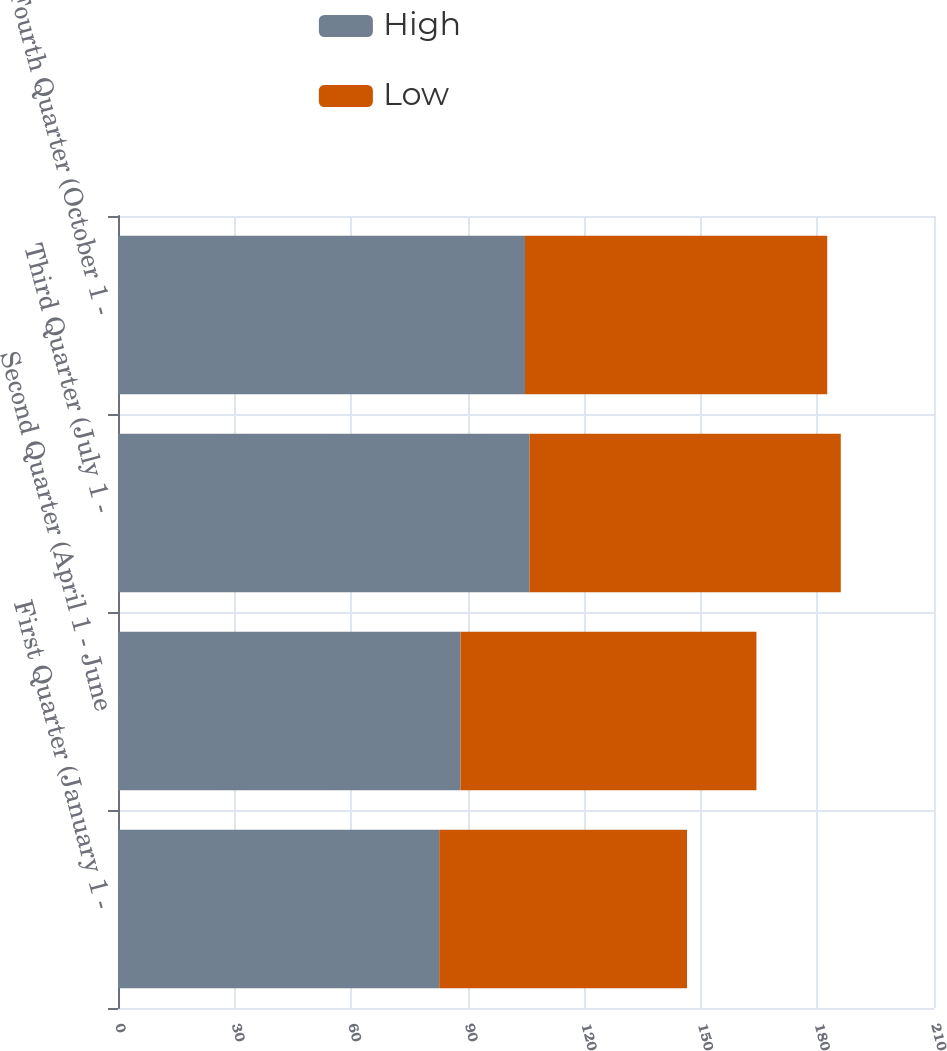Convert chart to OTSL. <chart><loc_0><loc_0><loc_500><loc_500><stacked_bar_chart><ecel><fcel>First Quarter (January 1 -<fcel>Second Quarter (April 1 - June<fcel>Third Quarter (July 1 -<fcel>Fourth Quarter (October 1 -<nl><fcel>High<fcel>82.67<fcel>88.15<fcel>105.89<fcel>104.74<nl><fcel>Low<fcel>63.77<fcel>76.15<fcel>80.12<fcel>77.78<nl></chart> 